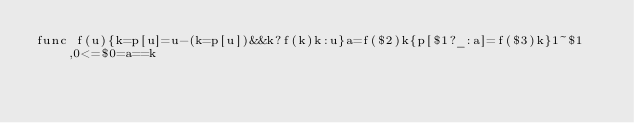Convert code to text. <code><loc_0><loc_0><loc_500><loc_500><_Awk_>func f(u){k=p[u]=u-(k=p[u])&&k?f(k)k:u}a=f($2)k{p[$1?_:a]=f($3)k}1~$1,0<=$0=a==k</code> 